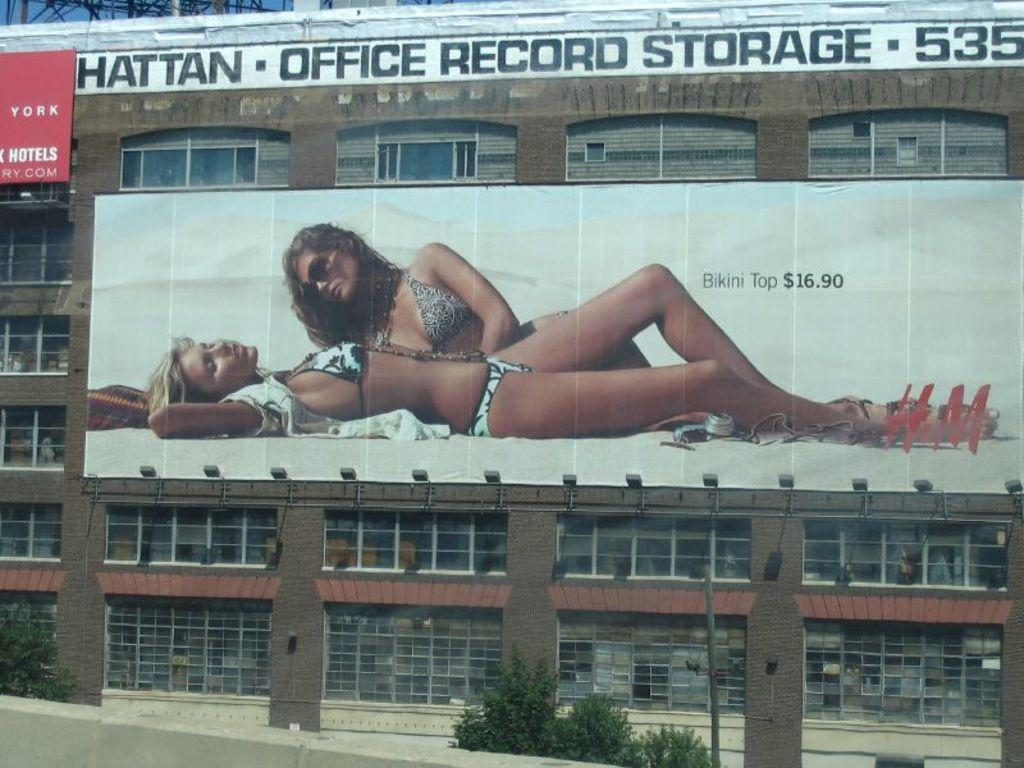<image>
Summarize the visual content of the image. Ba  er on a building with two models for HM on a building 